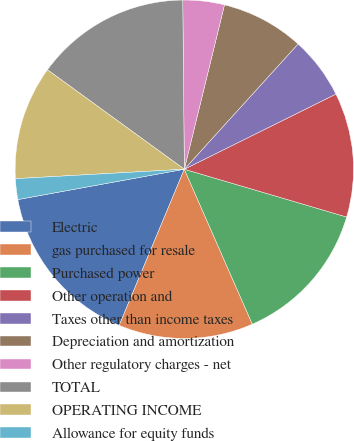Convert chart to OTSL. <chart><loc_0><loc_0><loc_500><loc_500><pie_chart><fcel>Electric<fcel>gas purchased for resale<fcel>Purchased power<fcel>Other operation and<fcel>Taxes other than income taxes<fcel>Depreciation and amortization<fcel>Other regulatory charges - net<fcel>TOTAL<fcel>OPERATING INCOME<fcel>Allowance for equity funds<nl><fcel>15.84%<fcel>12.87%<fcel>13.86%<fcel>11.88%<fcel>5.94%<fcel>7.92%<fcel>3.96%<fcel>14.85%<fcel>10.89%<fcel>1.98%<nl></chart> 